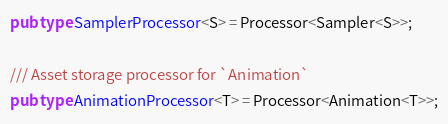Convert code to text. <code><loc_0><loc_0><loc_500><loc_500><_Rust_>pub type SamplerProcessor<S> = Processor<Sampler<S>>;

/// Asset storage processor for `Animation`
pub type AnimationProcessor<T> = Processor<Animation<T>>;
</code> 